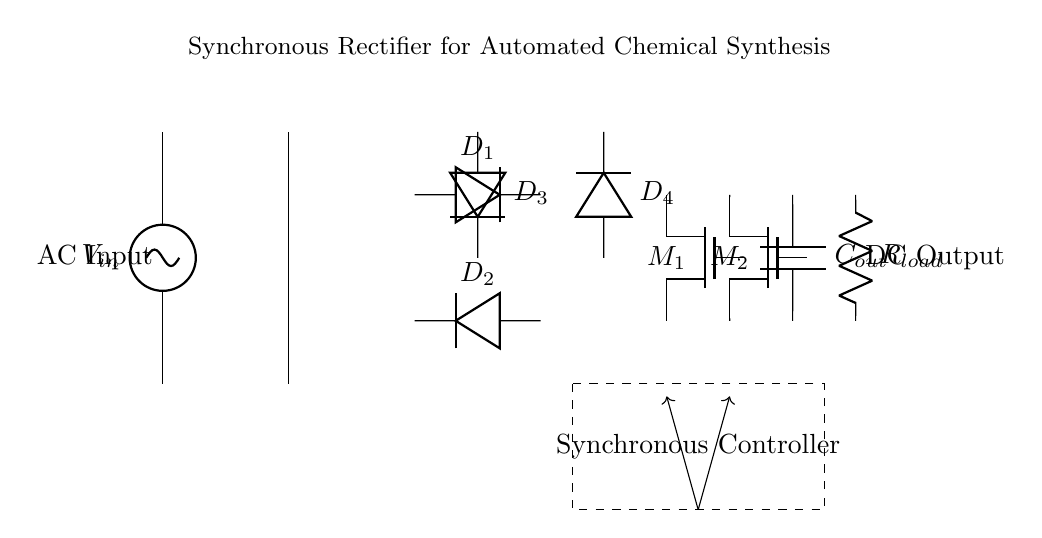What type of rectifier is shown in the circuit? The circuit employs a synchronous rectifier design, indicated by the presence of both diodes and MOSFETs for rectification. The synchronous controller further confirms its operation as a synchronous rectifier.
Answer: synchronous rectifier How many diodes are used in this rectifier circuit? The circuit displays a total of four diodes, labeled as D1, D2, D3, and D4. Careful examination shows that they are arranged in a bridge configuration typical of rectifiers.
Answer: four What is the role of the MOSFETs in this circuit? The MOSFETs, labeled M1 and M2, serve as synchronous switches that replace traditional diodes to enhance efficiency during the rectification process. Their presence is a key feature of synchronous rectifiers aimed at reducing power loss.
Answer: enhance efficiency What component is responsible for smoothing the output voltage? The output capacitor, labeled Cout, smooths the output voltage by storing energy and releasing it to the load, thus reducing voltage ripple after rectification. This is crucial in providing a stable DC output.
Answer: Cout What does the dashed rectangle represent in the circuit? The dashed rectangle encloses the synchronous controller, which manages the operation of the MOSFETs. Its placement indicates that it is a vital part of the circuit for controlling the switching process in the synchronous rectifier.
Answer: synchronous controller What is the load connected to in the circuit? The load is represented by the resistor labeled Rload, which draws power from the rectified DC output, demonstrating how the circuit provides energy to an external component or system.
Answer: Rload 